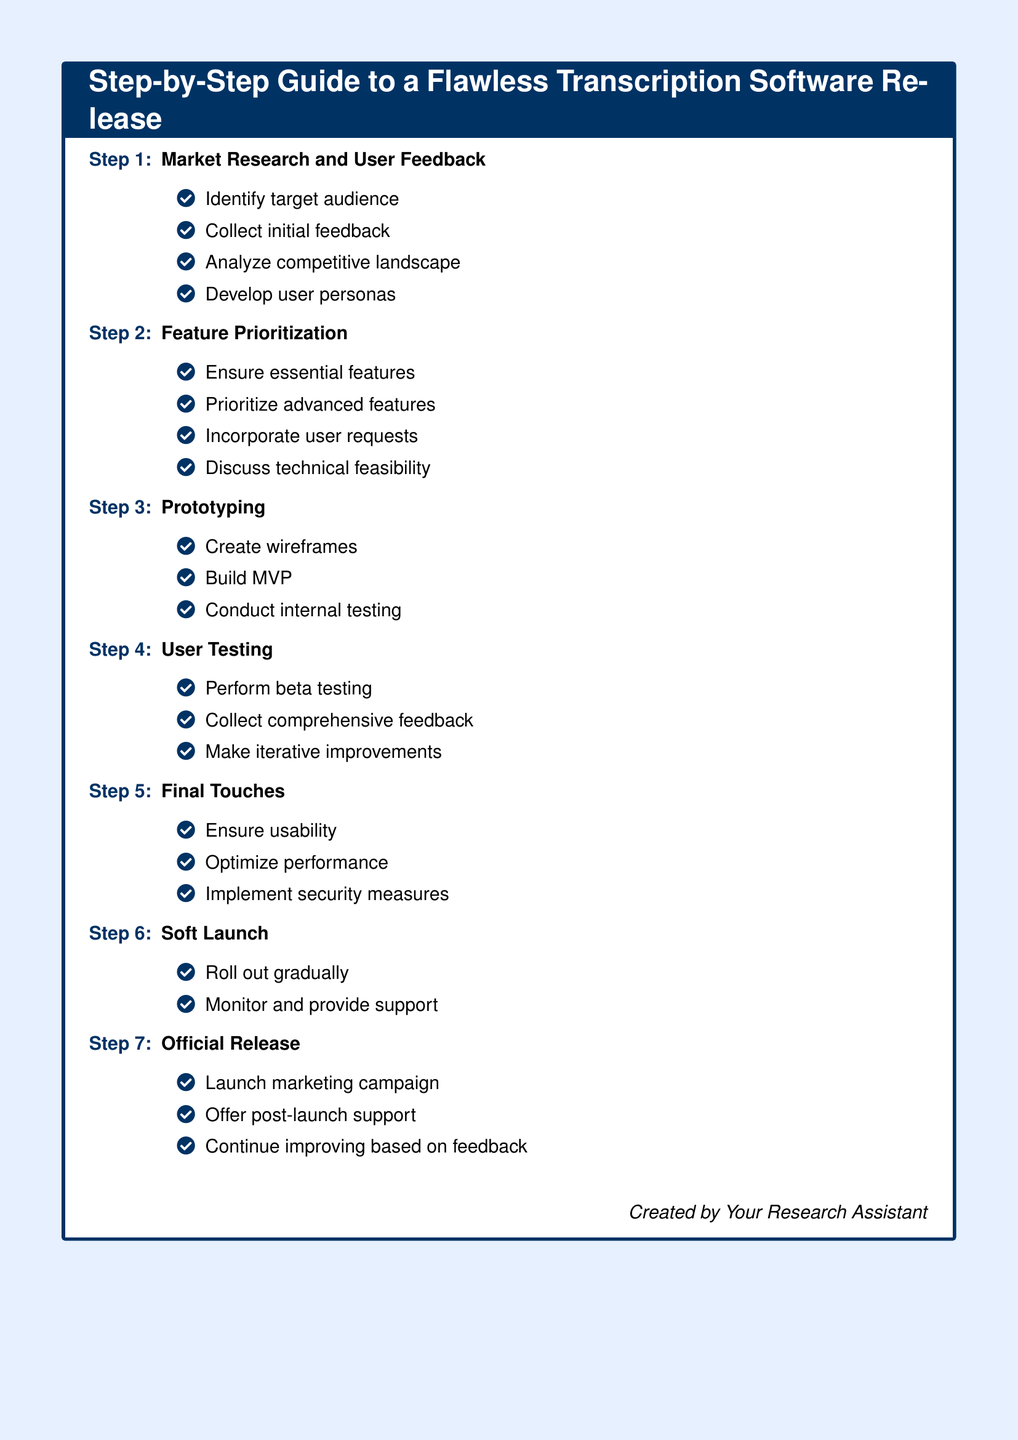What is the first step in the guide? The first step in the guide is stated in the list at the beginning of the document.
Answer: Market Research and User Feedback How many items are listed under User Testing? The number of items is counted from the bullet points under the User Testing section.
Answer: Three What is one of the tasks involved in Prototyping? One of the tasks can be found in the list of tasks under the Prototyping step.
Answer: Create wireframes Which step includes performing beta testing? The step is identified in the title of the corresponding section in the document.
Answer: User Testing What is the main focus of the Final Touches step? The focus can be inferred from the tasks outlined under the Final Touches section.
Answer: Usability In which step is a marketing campaign launched? The relevant step is named directly in the list of steps towards the end of the document.
Answer: Official Release How many total steps are outlined in the guide? The total number of steps can be counted from the enumerated list at the beginning of the document.
Answer: Seven Which aspect is emphasized during the Soft Launch? The emphasis is derived from the tasks described in the Soft Launch section.
Answer: Support 